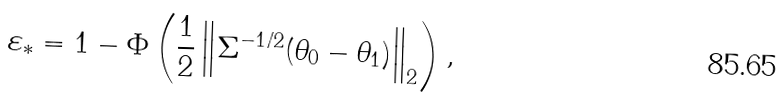Convert formula to latex. <formula><loc_0><loc_0><loc_500><loc_500>\varepsilon _ { * } = 1 - \Phi \left ( \frac { 1 } { 2 } \left \| \Sigma ^ { - 1 / 2 } ( \theta _ { 0 } - \theta _ { 1 } ) \right \| _ { 2 } \right ) ,</formula> 